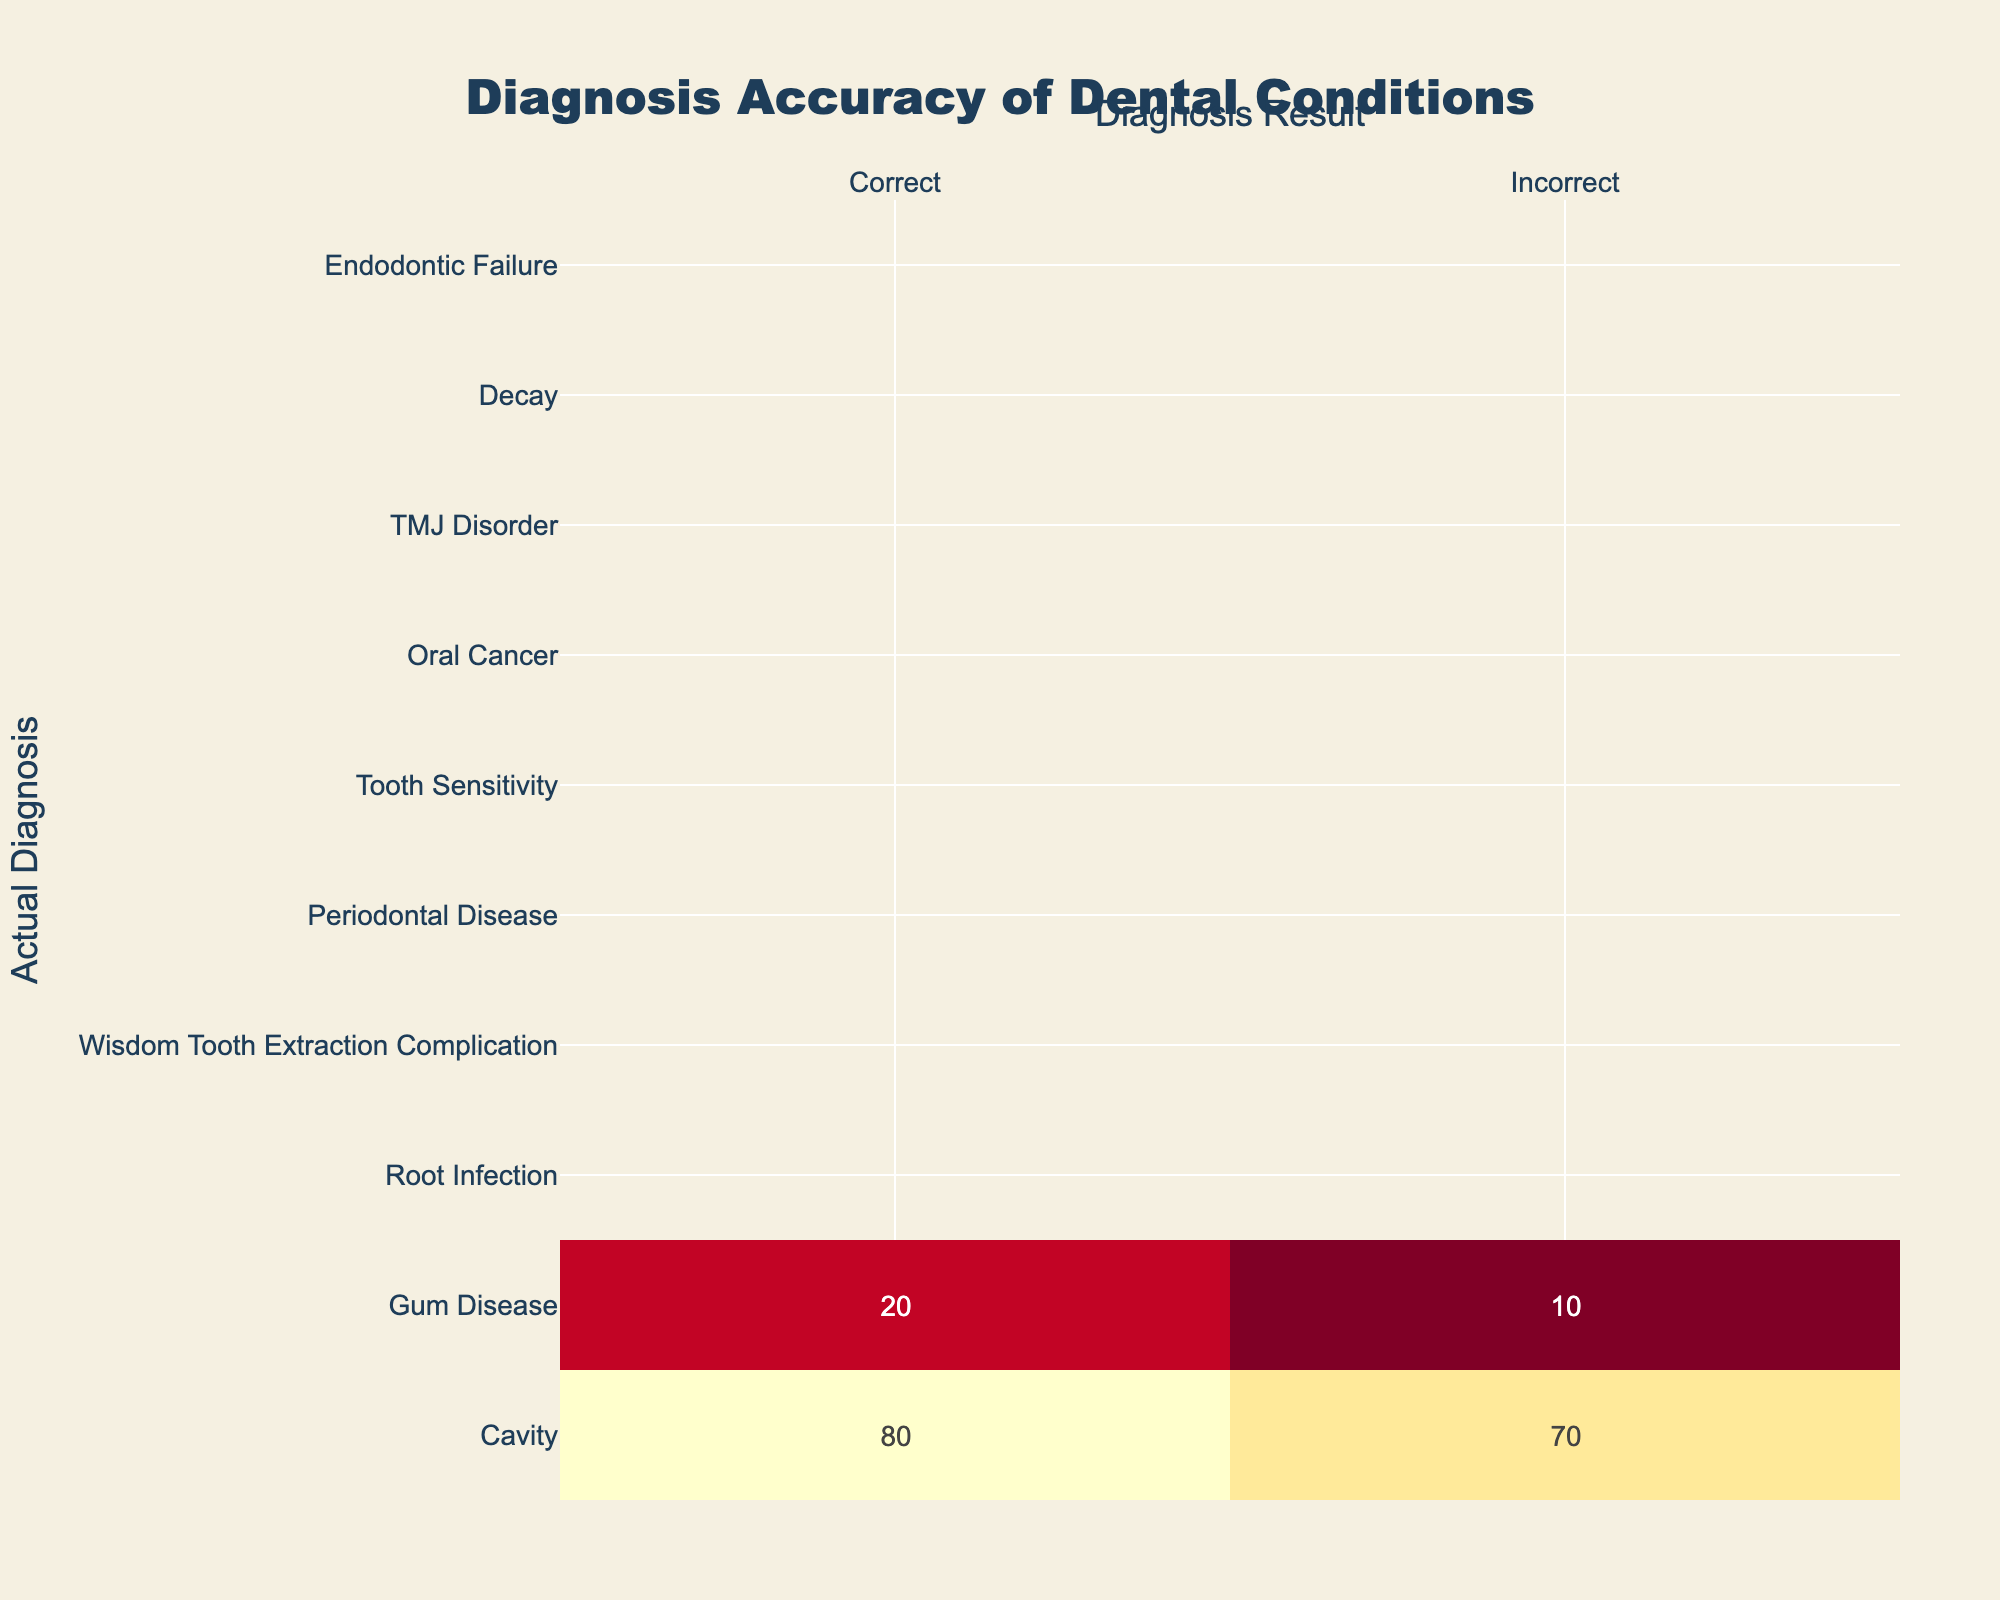What is the total number of correct diagnoses for Cavity? Looking at the row for Cavity, the value under Correct Diagnosis is 80. Therefore, the total number of correct diagnoses for this condition is simply that value.
Answer: 80 What is the difference in the number of correct diagnoses between Oral Cancer and Wisdom Tooth Extraction Complication? For Oral Cancer, the number of correct diagnoses is 92 and for Wisdom Tooth Extraction Complication, it is 30. The difference is calculated as 92 - 30 = 62.
Answer: 62 Is the total number of incorrect diagnoses for Gum Disease greater than that for TMJ Disorder? The number of incorrect diagnoses for Gum Disease is 10, while for TMJ Disorder, it is 10 as well. Since they are equal, the statement is false.
Answer: No What is the average number of incorrect diagnoses across all conditions? To find the average, first sum the incorrect diagnoses: 20 + 10 + 5 + 15 + 25 + 20 + 3 + 10 + 15 + 20 = 175. There are 10 conditions, so the average is 175 / 10 = 17.5.
Answer: 17.5 What is the total number of diagnoses (correct and incorrect) for Periodontal Disease? For Periodontal Disease, the correct diagnoses are 75 and incorrect diagnoses are 25. The total is found by adding these two values: 75 + 25 = 100.
Answer: 100 How many conditions have a higher correct diagnosis rate than Decay? For Decay, the correct diagnosis is 85. The conditions with higher correct diagnoses are: Oral Cancer (92) and Root Infection (90). This is a total of two conditions that exceed 85.
Answer: 2 Which condition has the highest number of incorrect diagnoses? By reviewing the incorrect diagnosis column, the highest value is 25 for Periodontal Disease.
Answer: Periodontal Disease What is the total number of correct diagnoses for all conditions combined? The numbers for correct diagnoses across all conditions are 80 + 70 + 90 + 30 + 75 + 60 + 92 + 55 + 85 + 40 = 712. This gives us the total correct diagnoses combined.
Answer: 712 Are there more conditions with incorrect diagnoses greater than 20 than those with correct diagnoses greater than 70? The conditions with incorrect diagnoses greater than 20 are Gum Disease, Wisdom Tooth Extraction Complication, Periodontal Disease, Tooth Sensitivity, Endodontic Failure, totaling five. The conditions with correct diagnoses greater than 70 are Cavity, Gum Disease, Root Infection, Oral Cancer, and Decay, totaling five. Therefore, there is no difference.
Answer: No 